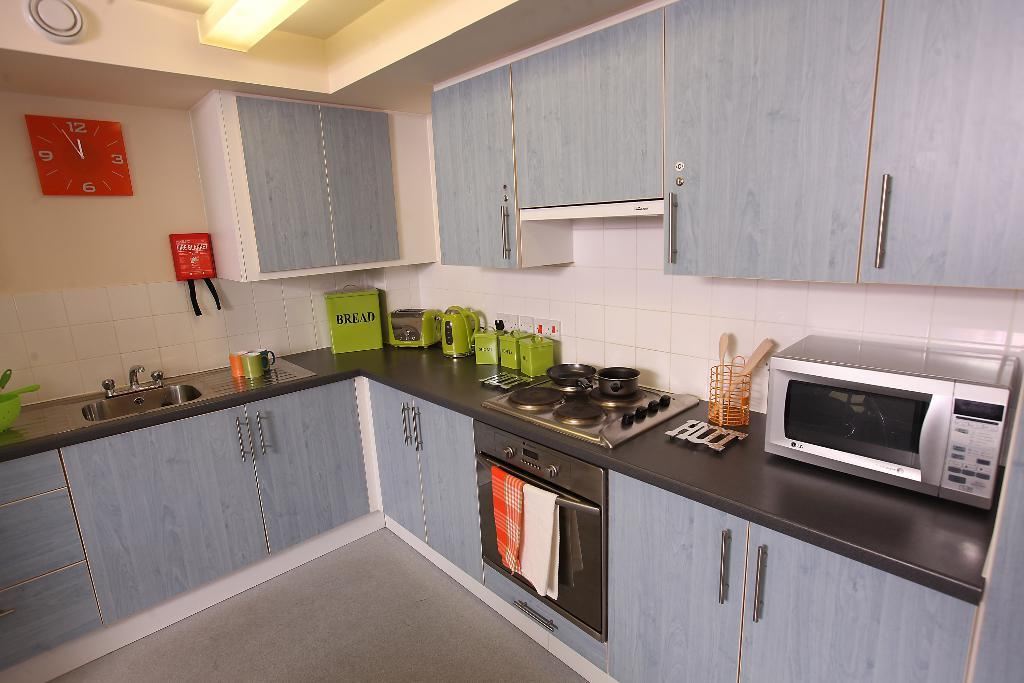<image>
Render a clear and concise summary of the photo. A kitchen with a green box that says bread 